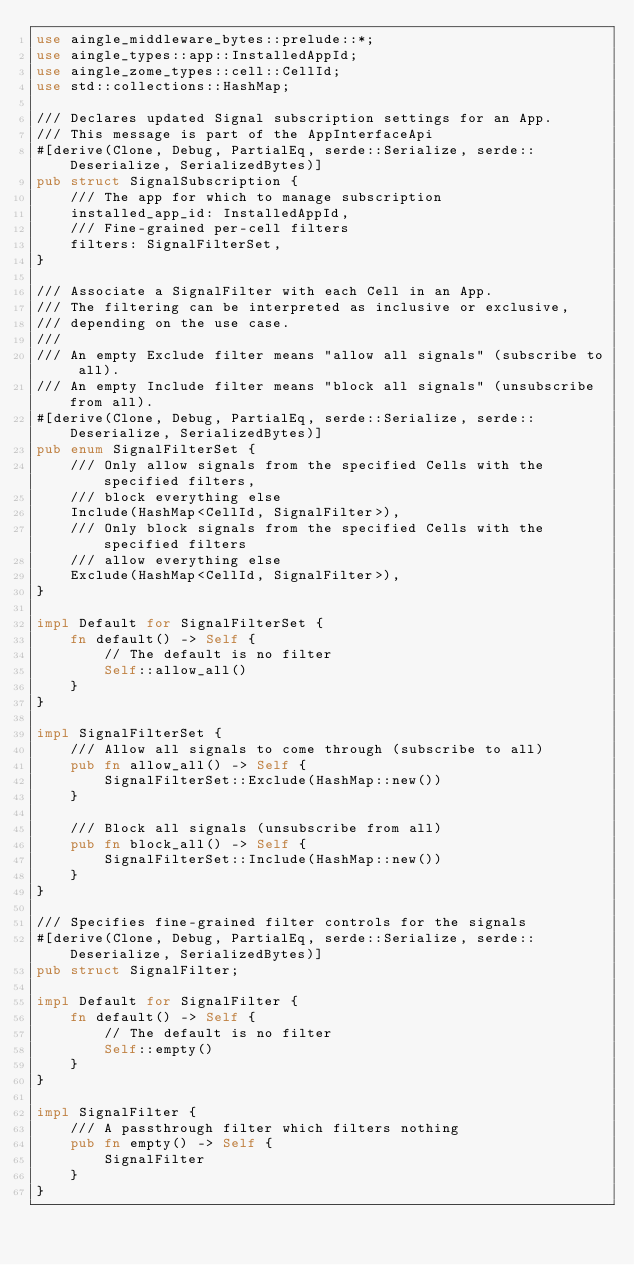<code> <loc_0><loc_0><loc_500><loc_500><_Rust_>use aingle_middleware_bytes::prelude::*;
use aingle_types::app::InstalledAppId;
use aingle_zome_types::cell::CellId;
use std::collections::HashMap;

/// Declares updated Signal subscription settings for an App.
/// This message is part of the AppInterfaceApi
#[derive(Clone, Debug, PartialEq, serde::Serialize, serde::Deserialize, SerializedBytes)]
pub struct SignalSubscription {
    /// The app for which to manage subscription
    installed_app_id: InstalledAppId,
    /// Fine-grained per-cell filters
    filters: SignalFilterSet,
}

/// Associate a SignalFilter with each Cell in an App.
/// The filtering can be interpreted as inclusive or exclusive,
/// depending on the use case.
///
/// An empty Exclude filter means "allow all signals" (subscribe to all).
/// An empty Include filter means "block all signals" (unsubscribe from all).
#[derive(Clone, Debug, PartialEq, serde::Serialize, serde::Deserialize, SerializedBytes)]
pub enum SignalFilterSet {
    /// Only allow signals from the specified Cells with the specified filters,
    /// block everything else
    Include(HashMap<CellId, SignalFilter>),
    /// Only block signals from the specified Cells with the specified filters
    /// allow everything else
    Exclude(HashMap<CellId, SignalFilter>),
}

impl Default for SignalFilterSet {
    fn default() -> Self {
        // The default is no filter
        Self::allow_all()
    }
}

impl SignalFilterSet {
    /// Allow all signals to come through (subscribe to all)
    pub fn allow_all() -> Self {
        SignalFilterSet::Exclude(HashMap::new())
    }

    /// Block all signals (unsubscribe from all)
    pub fn block_all() -> Self {
        SignalFilterSet::Include(HashMap::new())
    }
}

/// Specifies fine-grained filter controls for the signals
#[derive(Clone, Debug, PartialEq, serde::Serialize, serde::Deserialize, SerializedBytes)]
pub struct SignalFilter;

impl Default for SignalFilter {
    fn default() -> Self {
        // The default is no filter
        Self::empty()
    }
}

impl SignalFilter {
    /// A passthrough filter which filters nothing
    pub fn empty() -> Self {
        SignalFilter
    }
}
</code> 